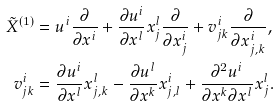<formula> <loc_0><loc_0><loc_500><loc_500>\tilde { X } ^ { ( 1 ) } & = u ^ { i } \frac { \partial } { \partial x ^ { i } } + \frac { \partial u ^ { i } } { \partial x ^ { l } } x _ { j } ^ { l } \frac { \partial } { \partial x _ { j } ^ { i } } + v _ { j k } ^ { i } \frac { \partial } { \partial x _ { j , k } ^ { i } } , \\ v _ { j k } ^ { i } & = \frac { \partial u ^ { i } } { \partial x ^ { l } } x _ { j , k } ^ { l } - \frac { \partial u ^ { l } } { \partial x ^ { k } } x _ { j , l } ^ { i } + \frac { \partial ^ { 2 } u ^ { i } } { \partial x ^ { k } \partial x ^ { l } } x _ { j } ^ { l } .</formula> 